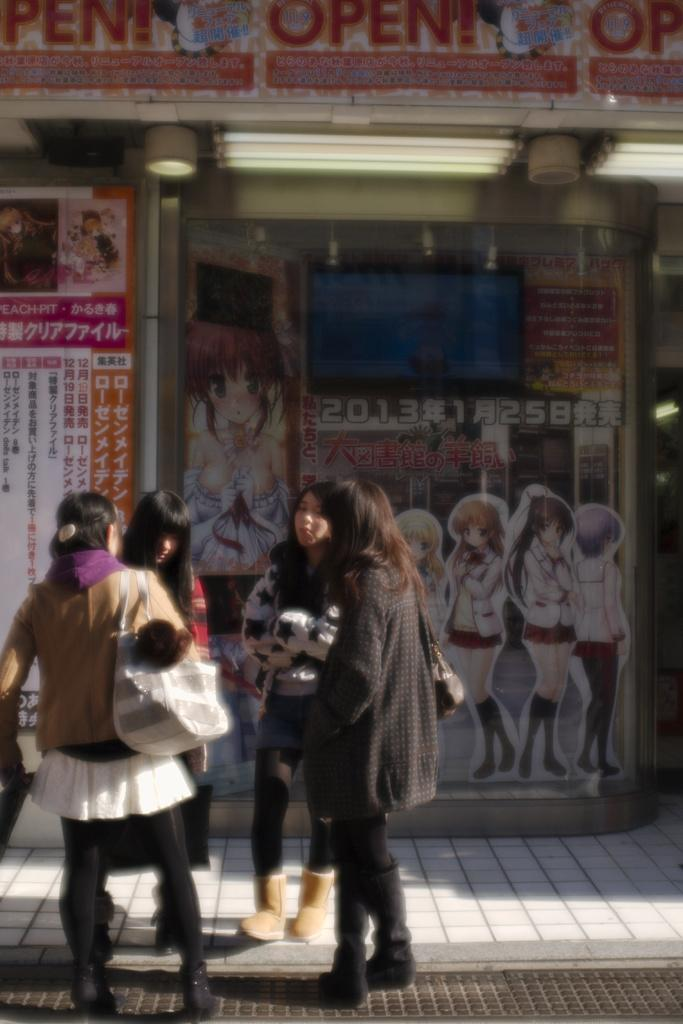How many people are present in the image? There are four girls standing in the image. What can be seen in the background of the image? There are posters in the background of the image. Can you describe the source of light be identified in the image? Yes, there is a light can be seen at the top of the image. What type of tree is growing in the middle of the image? There is no tree present in the image; it only features four girls, posters in the background, and a light at the top. Is there a man playing a guitar in the image? There is no man or guitar present in the image. 